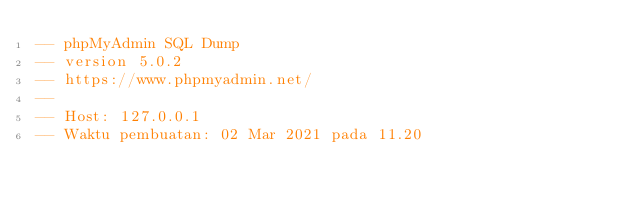Convert code to text. <code><loc_0><loc_0><loc_500><loc_500><_SQL_>-- phpMyAdmin SQL Dump
-- version 5.0.2
-- https://www.phpmyadmin.net/
--
-- Host: 127.0.0.1
-- Waktu pembuatan: 02 Mar 2021 pada 11.20</code> 